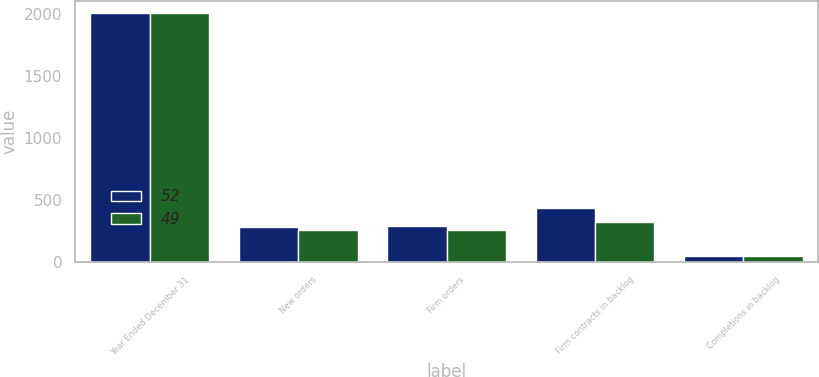Convert chart. <chart><loc_0><loc_0><loc_500><loc_500><stacked_bar_chart><ecel><fcel>Year Ended December 31<fcel>New orders<fcel>Firm orders<fcel>Firm contracts in backlog<fcel>Completions in backlog<nl><fcel>52<fcel>2008<fcel>280<fcel>288<fcel>438<fcel>52<nl><fcel>49<fcel>2007<fcel>256<fcel>257<fcel>320<fcel>49<nl></chart> 